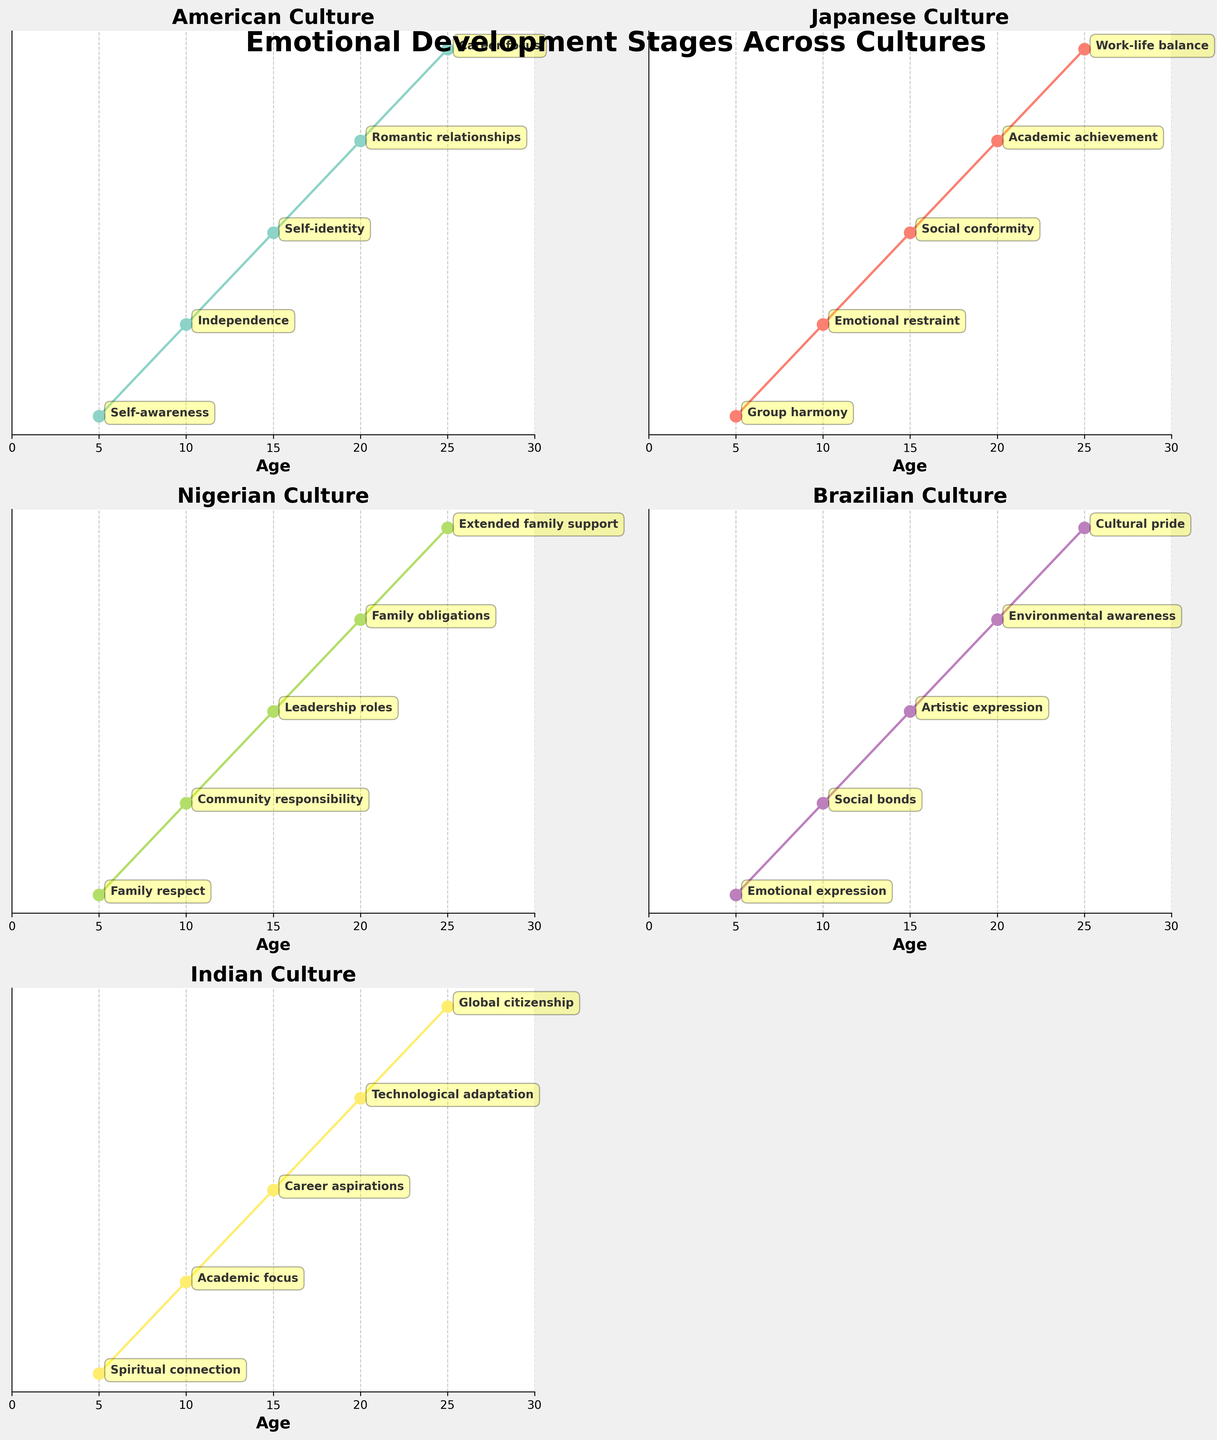What is the title of the plot? The main title of the plot is located at the top and usually describes the overall content of the visual. The main title here is "Emotional Development Stages Across Cultures."
Answer: Emotional Development Stages Across Cultures How many subplots are there in total? By examining the grid layout and counting the number of individual plots, you will notice there are supposed to be 6 subplots, but one is removed. So there are 5 subplots.
Answer: 5 At what age do American children start focusing on "Career focus"? By looking at the American Culture subplot, locate the stage named "Career focus" and check the corresponding age on the x-axis. "Career focus" appears at age 25.
Answer: 25 Which culture prioritizes "Group harmony" at the youngest age? By investigating each subplot, identify the emotional development stage "Group harmony" and find the corresponding age. Only the Japanese subplot lists "Group harmony" at age 5.
Answer: Japanese How does the Brazilian culture's focus shift from age 5 to age 20? Review the Brazilian Culture subplot and read the annotations corresponding to ages 5, 10, 15, and 20. The stages go from "Emotional expression" at 5, to "Social bonds" at 10, to "Artistic expression" at 15, and to "Environmental awareness" at 20.
Answer: Emotional expression → Social bonds → Artistic expression → Environmental awareness Which culture emphasizes "Family respect" and at what age does this emphasis occur? Look through each subplot to find the emotional development stage "Family respect" and note its corresponding age and culture. It's emphasized in Nigerian culture at age 5.
Answer: Nigerian, 5 Between ages 10 and 20, what is the new focus for Indian children? Refer to the Indian subplot and compare the stages at age 10 and age 20. At age 10, the focus is "Academic focus" and at age 20 it shifts to "Technological adaptation."
Answer: Technological adaptation Which culture puts emphasis on "Extended family support" by age 25? Locate the stage "Extended family support" in the subplots and see which culture it aligns with at age 25. The subplot for Nigerian culture shows "Extended family support" at this age.
Answer: Nigerian How does the focus at age 10 compare between American children and Japanese children? Look at the American and Japanese subplots and note the stages at age 10. For Americans, the stage is "Independence" whereas for Japanese, it is "Emotional restraint."
Answer: Independence vs Emotional restraint What are the stages observed in Indian children from age 5 to age 25? Examine the Indian Culture subplot and list the stages from age 5 to 25: "Spiritual connection" at 5, "Academic focus" at 10, "Career aspirations" at 15, "Technological adaptation" at 20, and "Global citizenship" at 25.
Answer: Spiritual connection → Academic focus → Career aspirations → Technological adaptation → Global citizenship 